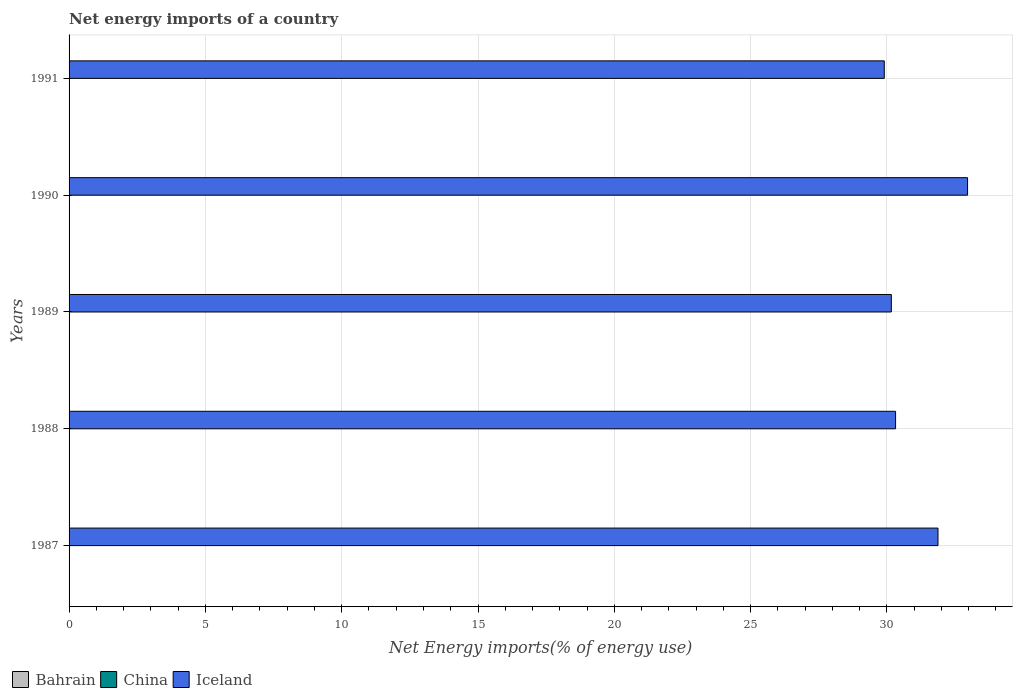How many different coloured bars are there?
Your answer should be very brief. 1. Are the number of bars per tick equal to the number of legend labels?
Your answer should be very brief. No. How many bars are there on the 2nd tick from the top?
Keep it short and to the point. 1. How many bars are there on the 3rd tick from the bottom?
Offer a terse response. 1. What is the label of the 3rd group of bars from the top?
Offer a terse response. 1989. What is the net energy imports in Iceland in 1989?
Keep it short and to the point. 30.16. Across all years, what is the maximum net energy imports in Iceland?
Provide a short and direct response. 32.96. Across all years, what is the minimum net energy imports in Iceland?
Ensure brevity in your answer.  29.9. In which year was the net energy imports in Iceland maximum?
Your response must be concise. 1990. What is the total net energy imports in Iceland in the graph?
Offer a very short reply. 155.21. What is the difference between the net energy imports in Iceland in 1987 and that in 1991?
Your answer should be very brief. 1.97. What is the difference between the net energy imports in Iceland in 1990 and the net energy imports in Bahrain in 1987?
Your answer should be compact. 32.96. What is the average net energy imports in Iceland per year?
Give a very brief answer. 31.04. In how many years, is the net energy imports in Bahrain greater than 15 %?
Keep it short and to the point. 0. What is the ratio of the net energy imports in Iceland in 1987 to that in 1988?
Give a very brief answer. 1.05. Is the net energy imports in Iceland in 1987 less than that in 1991?
Offer a terse response. No. What is the difference between the highest and the second highest net energy imports in Iceland?
Your answer should be very brief. 1.08. What is the difference between the highest and the lowest net energy imports in Iceland?
Your response must be concise. 3.05. Is the sum of the net energy imports in Iceland in 1989 and 1991 greater than the maximum net energy imports in Bahrain across all years?
Give a very brief answer. Yes. Are all the bars in the graph horizontal?
Provide a short and direct response. Yes. How many years are there in the graph?
Your response must be concise. 5. What is the difference between two consecutive major ticks on the X-axis?
Give a very brief answer. 5. Are the values on the major ticks of X-axis written in scientific E-notation?
Offer a terse response. No. Does the graph contain any zero values?
Offer a very short reply. Yes. Does the graph contain grids?
Provide a succinct answer. Yes. How are the legend labels stacked?
Provide a succinct answer. Horizontal. What is the title of the graph?
Your answer should be very brief. Net energy imports of a country. Does "East Asia (developing only)" appear as one of the legend labels in the graph?
Ensure brevity in your answer.  No. What is the label or title of the X-axis?
Give a very brief answer. Net Energy imports(% of energy use). What is the label or title of the Y-axis?
Offer a terse response. Years. What is the Net Energy imports(% of energy use) of China in 1987?
Provide a short and direct response. 0. What is the Net Energy imports(% of energy use) in Iceland in 1987?
Your answer should be very brief. 31.87. What is the Net Energy imports(% of energy use) in Iceland in 1988?
Provide a short and direct response. 30.32. What is the Net Energy imports(% of energy use) of China in 1989?
Provide a succinct answer. 0. What is the Net Energy imports(% of energy use) of Iceland in 1989?
Ensure brevity in your answer.  30.16. What is the Net Energy imports(% of energy use) in China in 1990?
Make the answer very short. 0. What is the Net Energy imports(% of energy use) of Iceland in 1990?
Keep it short and to the point. 32.96. What is the Net Energy imports(% of energy use) of Iceland in 1991?
Make the answer very short. 29.9. Across all years, what is the maximum Net Energy imports(% of energy use) of Iceland?
Your response must be concise. 32.96. Across all years, what is the minimum Net Energy imports(% of energy use) of Iceland?
Provide a succinct answer. 29.9. What is the total Net Energy imports(% of energy use) of Bahrain in the graph?
Provide a short and direct response. 0. What is the total Net Energy imports(% of energy use) of China in the graph?
Provide a short and direct response. 0. What is the total Net Energy imports(% of energy use) in Iceland in the graph?
Your answer should be compact. 155.21. What is the difference between the Net Energy imports(% of energy use) in Iceland in 1987 and that in 1988?
Offer a very short reply. 1.56. What is the difference between the Net Energy imports(% of energy use) in Iceland in 1987 and that in 1989?
Provide a short and direct response. 1.71. What is the difference between the Net Energy imports(% of energy use) in Iceland in 1987 and that in 1990?
Offer a very short reply. -1.08. What is the difference between the Net Energy imports(% of energy use) of Iceland in 1987 and that in 1991?
Offer a very short reply. 1.97. What is the difference between the Net Energy imports(% of energy use) in Iceland in 1988 and that in 1989?
Make the answer very short. 0.16. What is the difference between the Net Energy imports(% of energy use) of Iceland in 1988 and that in 1990?
Provide a short and direct response. -2.64. What is the difference between the Net Energy imports(% of energy use) of Iceland in 1988 and that in 1991?
Offer a very short reply. 0.41. What is the difference between the Net Energy imports(% of energy use) in Iceland in 1989 and that in 1990?
Ensure brevity in your answer.  -2.8. What is the difference between the Net Energy imports(% of energy use) of Iceland in 1989 and that in 1991?
Give a very brief answer. 0.26. What is the difference between the Net Energy imports(% of energy use) of Iceland in 1990 and that in 1991?
Provide a short and direct response. 3.05. What is the average Net Energy imports(% of energy use) of Bahrain per year?
Keep it short and to the point. 0. What is the average Net Energy imports(% of energy use) of China per year?
Your answer should be very brief. 0. What is the average Net Energy imports(% of energy use) in Iceland per year?
Your answer should be compact. 31.04. What is the ratio of the Net Energy imports(% of energy use) of Iceland in 1987 to that in 1988?
Ensure brevity in your answer.  1.05. What is the ratio of the Net Energy imports(% of energy use) of Iceland in 1987 to that in 1989?
Provide a succinct answer. 1.06. What is the ratio of the Net Energy imports(% of energy use) in Iceland in 1987 to that in 1990?
Keep it short and to the point. 0.97. What is the ratio of the Net Energy imports(% of energy use) in Iceland in 1987 to that in 1991?
Your answer should be very brief. 1.07. What is the ratio of the Net Energy imports(% of energy use) in Iceland in 1988 to that in 1990?
Your response must be concise. 0.92. What is the ratio of the Net Energy imports(% of energy use) of Iceland in 1988 to that in 1991?
Offer a terse response. 1.01. What is the ratio of the Net Energy imports(% of energy use) of Iceland in 1989 to that in 1990?
Ensure brevity in your answer.  0.92. What is the ratio of the Net Energy imports(% of energy use) in Iceland in 1989 to that in 1991?
Offer a very short reply. 1.01. What is the ratio of the Net Energy imports(% of energy use) in Iceland in 1990 to that in 1991?
Make the answer very short. 1.1. What is the difference between the highest and the second highest Net Energy imports(% of energy use) of Iceland?
Ensure brevity in your answer.  1.08. What is the difference between the highest and the lowest Net Energy imports(% of energy use) in Iceland?
Keep it short and to the point. 3.05. 